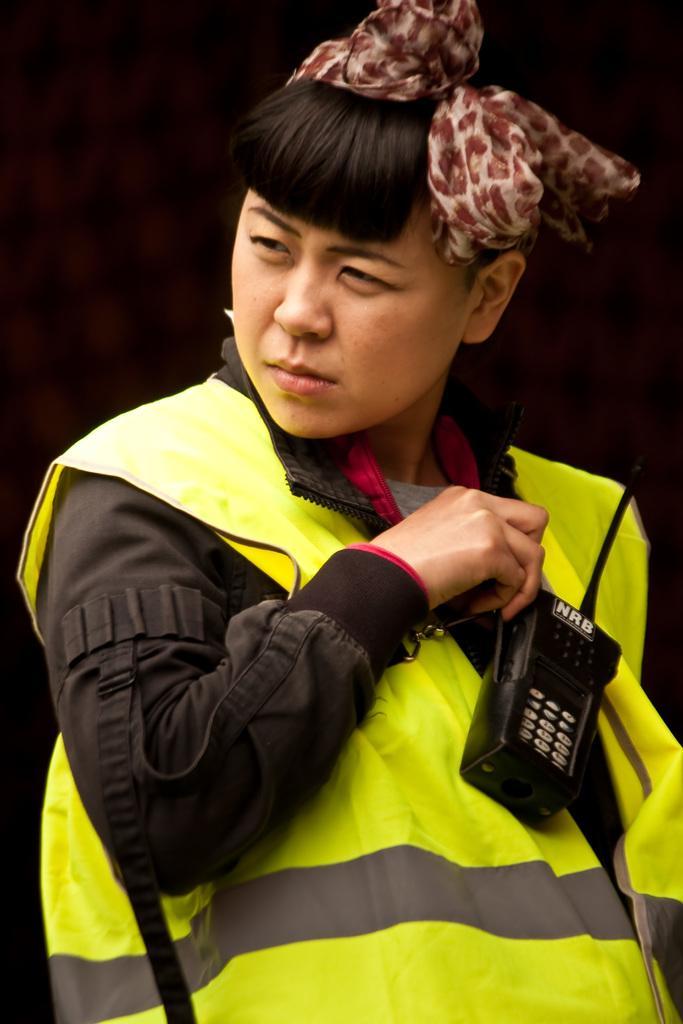In one or two sentences, can you explain what this image depicts? In the center of the image, we can see a person wearing a coat, a headband and holding an object and the background is dark. 